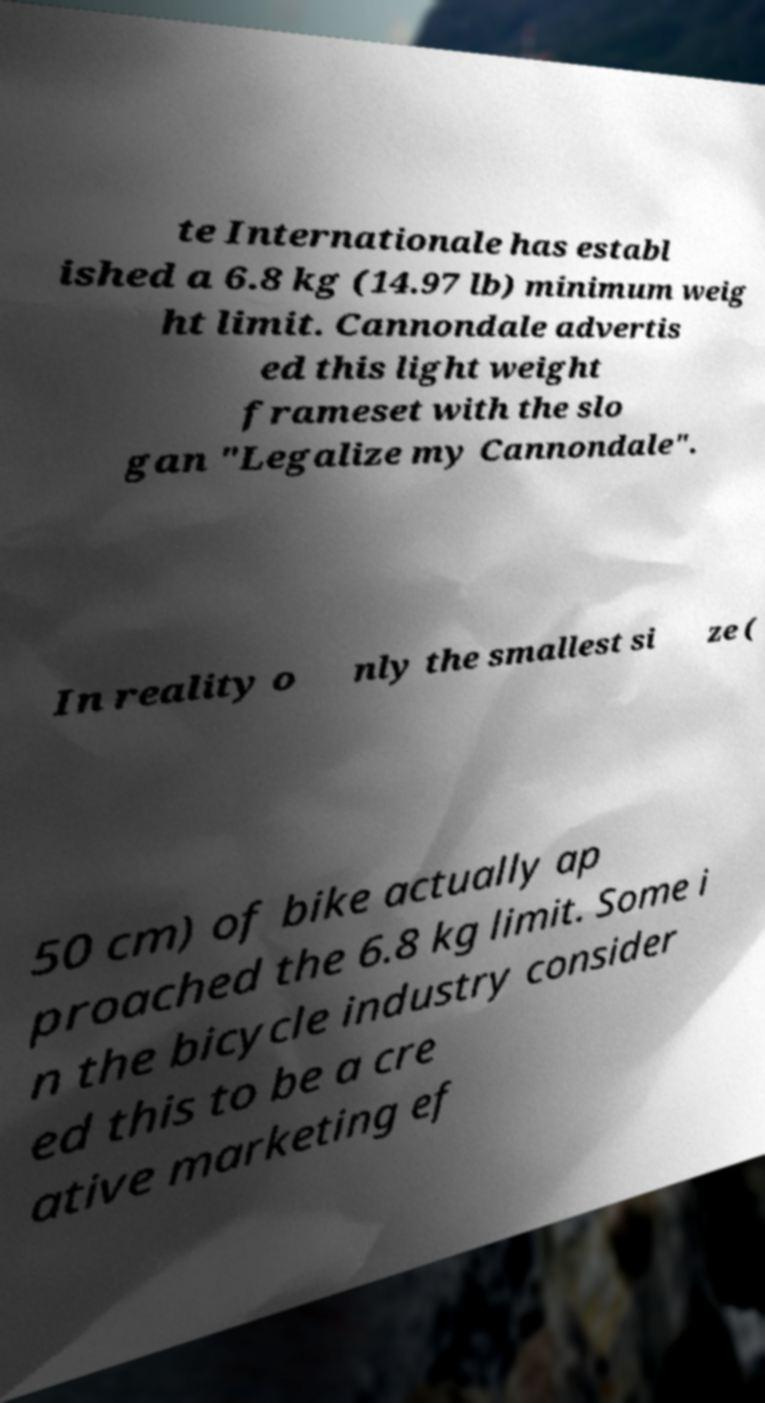Please read and relay the text visible in this image. What does it say? te Internationale has establ ished a 6.8 kg (14.97 lb) minimum weig ht limit. Cannondale advertis ed this light weight frameset with the slo gan "Legalize my Cannondale". In reality o nly the smallest si ze ( 50 cm) of bike actually ap proached the 6.8 kg limit. Some i n the bicycle industry consider ed this to be a cre ative marketing ef 